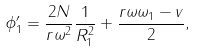<formula> <loc_0><loc_0><loc_500><loc_500>\phi _ { 1 } ^ { \prime } = \frac { 2 N } { r \omega ^ { 2 } } \frac { 1 } { R _ { 1 } ^ { 2 } } + \frac { r \omega \omega _ { 1 } - v } { 2 } ,</formula> 